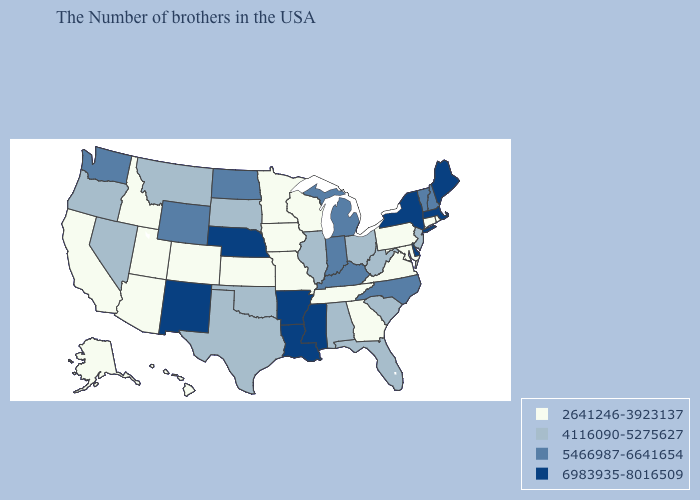Which states have the highest value in the USA?
Be succinct. Maine, Massachusetts, New York, Delaware, Mississippi, Louisiana, Arkansas, Nebraska, New Mexico. Does Connecticut have the same value as Alaska?
Keep it brief. Yes. Among the states that border West Virginia , does Kentucky have the lowest value?
Keep it brief. No. Does the map have missing data?
Give a very brief answer. No. Which states have the highest value in the USA?
Answer briefly. Maine, Massachusetts, New York, Delaware, Mississippi, Louisiana, Arkansas, Nebraska, New Mexico. What is the lowest value in the USA?
Write a very short answer. 2641246-3923137. Which states have the lowest value in the USA?
Write a very short answer. Rhode Island, Connecticut, Maryland, Pennsylvania, Virginia, Georgia, Tennessee, Wisconsin, Missouri, Minnesota, Iowa, Kansas, Colorado, Utah, Arizona, Idaho, California, Alaska, Hawaii. What is the value of Maine?
Quick response, please. 6983935-8016509. What is the value of South Dakota?
Quick response, please. 4116090-5275627. What is the lowest value in the USA?
Write a very short answer. 2641246-3923137. Name the states that have a value in the range 2641246-3923137?
Give a very brief answer. Rhode Island, Connecticut, Maryland, Pennsylvania, Virginia, Georgia, Tennessee, Wisconsin, Missouri, Minnesota, Iowa, Kansas, Colorado, Utah, Arizona, Idaho, California, Alaska, Hawaii. How many symbols are there in the legend?
Be succinct. 4. What is the value of Montana?
Keep it brief. 4116090-5275627. Does Oklahoma have the lowest value in the South?
Short answer required. No. Name the states that have a value in the range 4116090-5275627?
Short answer required. New Jersey, South Carolina, West Virginia, Ohio, Florida, Alabama, Illinois, Oklahoma, Texas, South Dakota, Montana, Nevada, Oregon. 